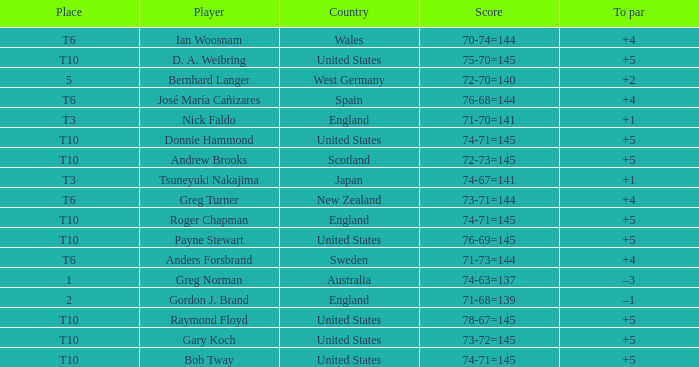What was Anders Forsbrand's score when the TO par is +4? 71-73=144. 